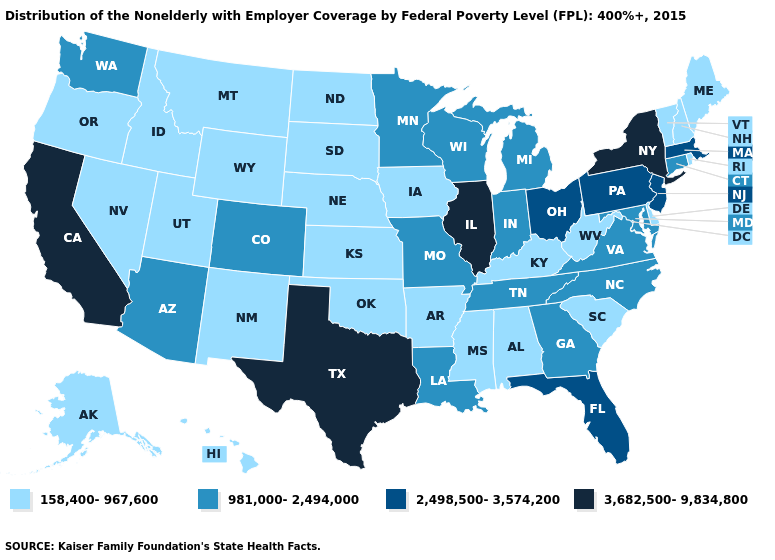Does Idaho have a higher value than Arkansas?
Answer briefly. No. Among the states that border Louisiana , does Mississippi have the lowest value?
Short answer required. Yes. Is the legend a continuous bar?
Be succinct. No. Which states hav the highest value in the West?
Short answer required. California. Which states have the highest value in the USA?
Quick response, please. California, Illinois, New York, Texas. What is the lowest value in the USA?
Be succinct. 158,400-967,600. What is the value of Arkansas?
Concise answer only. 158,400-967,600. Among the states that border Texas , does Louisiana have the highest value?
Keep it brief. Yes. Does Indiana have a lower value than Florida?
Quick response, please. Yes. What is the value of Oregon?
Give a very brief answer. 158,400-967,600. What is the highest value in the South ?
Give a very brief answer. 3,682,500-9,834,800. Does Connecticut have the lowest value in the Northeast?
Write a very short answer. No. What is the highest value in states that border Montana?
Concise answer only. 158,400-967,600. What is the value of Kansas?
Quick response, please. 158,400-967,600. Among the states that border Indiana , which have the highest value?
Write a very short answer. Illinois. 